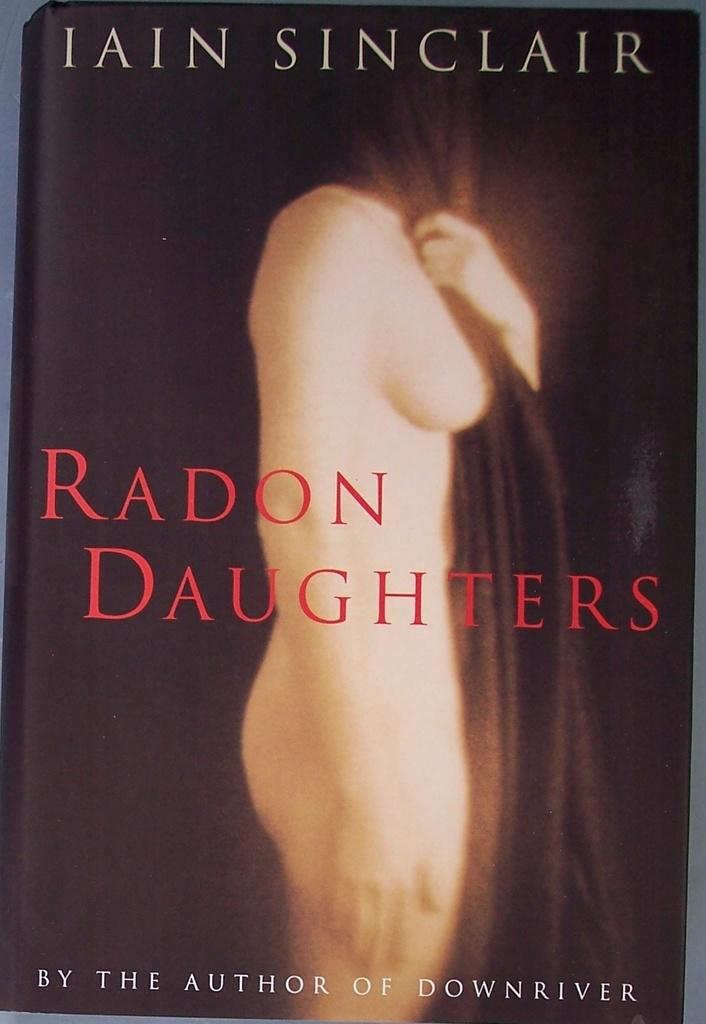What is the main subject of the image? The main subject of the image is the cover page of a book. What can be found on the cover page? There is text and an image on the cover page. What type of oatmeal is being served to the fairies in the image? There are no fairies or oatmeal present in the image; it features the cover page of a book with text and an image. 